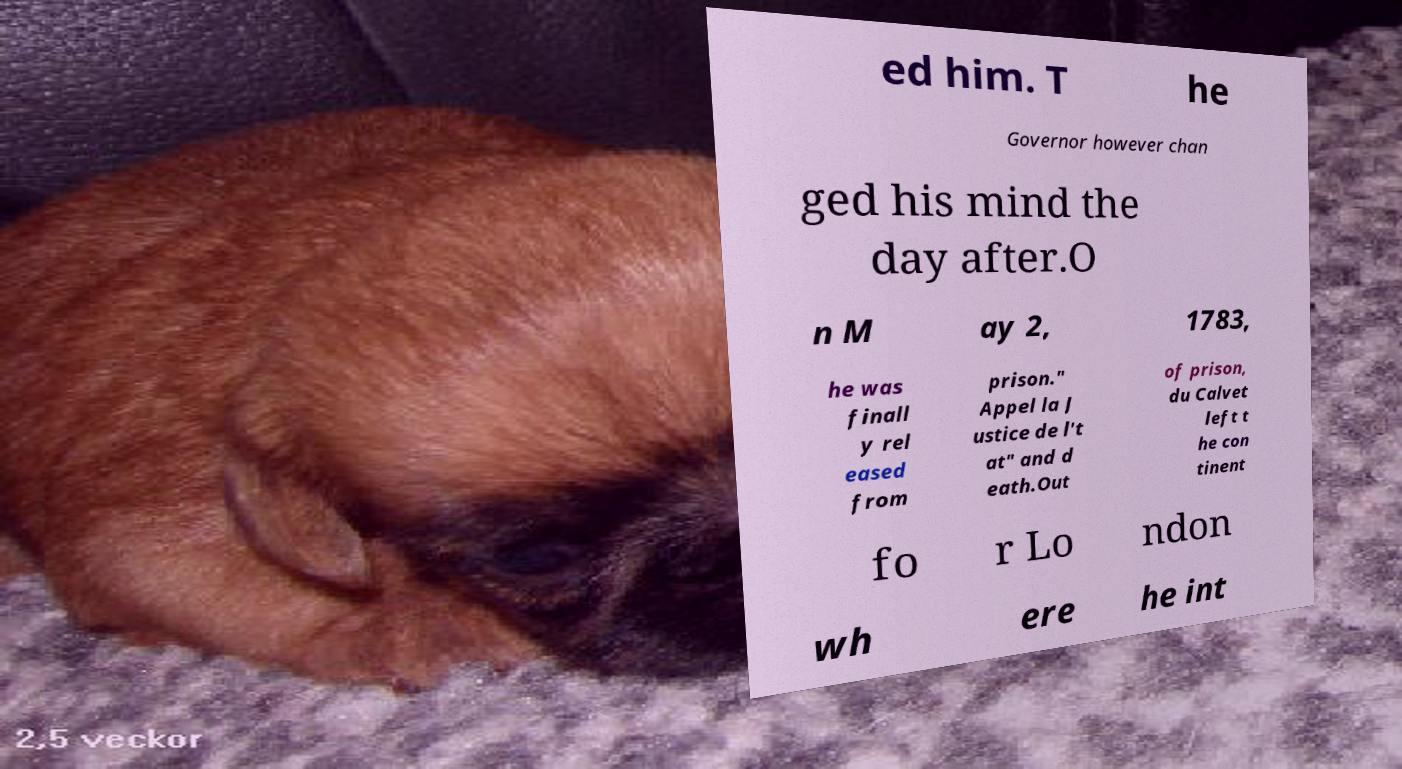Can you accurately transcribe the text from the provided image for me? ed him. T he Governor however chan ged his mind the day after.O n M ay 2, 1783, he was finall y rel eased from prison." Appel la J ustice de l't at" and d eath.Out of prison, du Calvet left t he con tinent fo r Lo ndon wh ere he int 